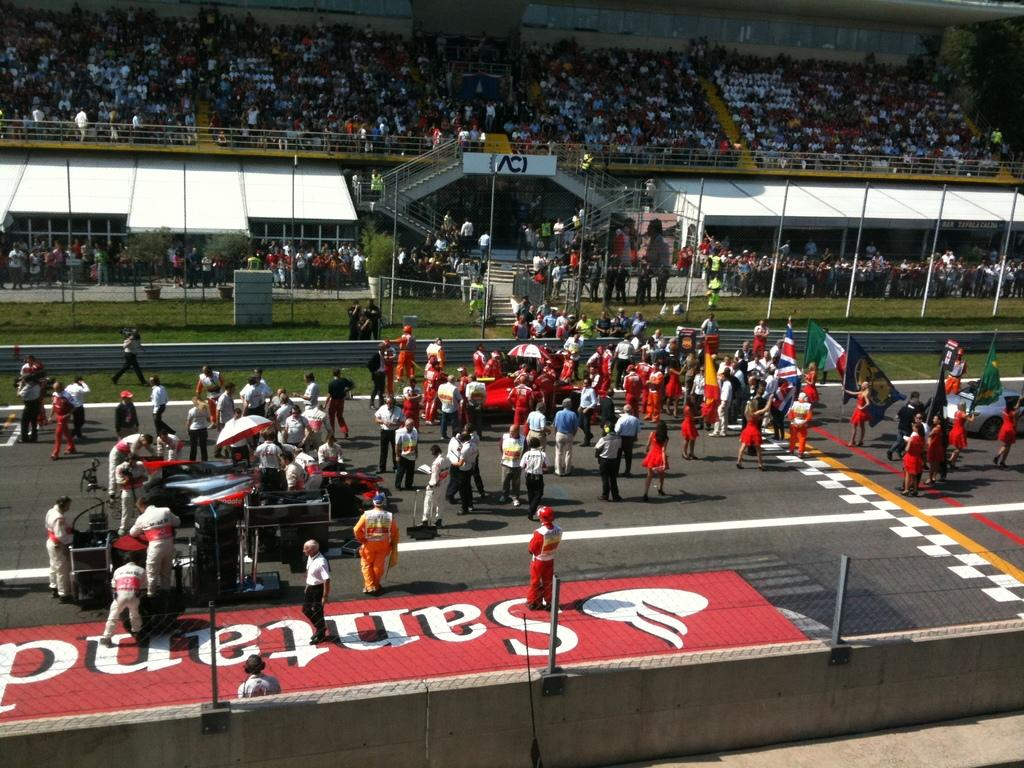<image>
Provide a brief description of the given image. A Santand logo is on the ground near a bunch of people wearing red. 